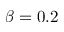Convert formula to latex. <formula><loc_0><loc_0><loc_500><loc_500>\beta = 0 . 2</formula> 